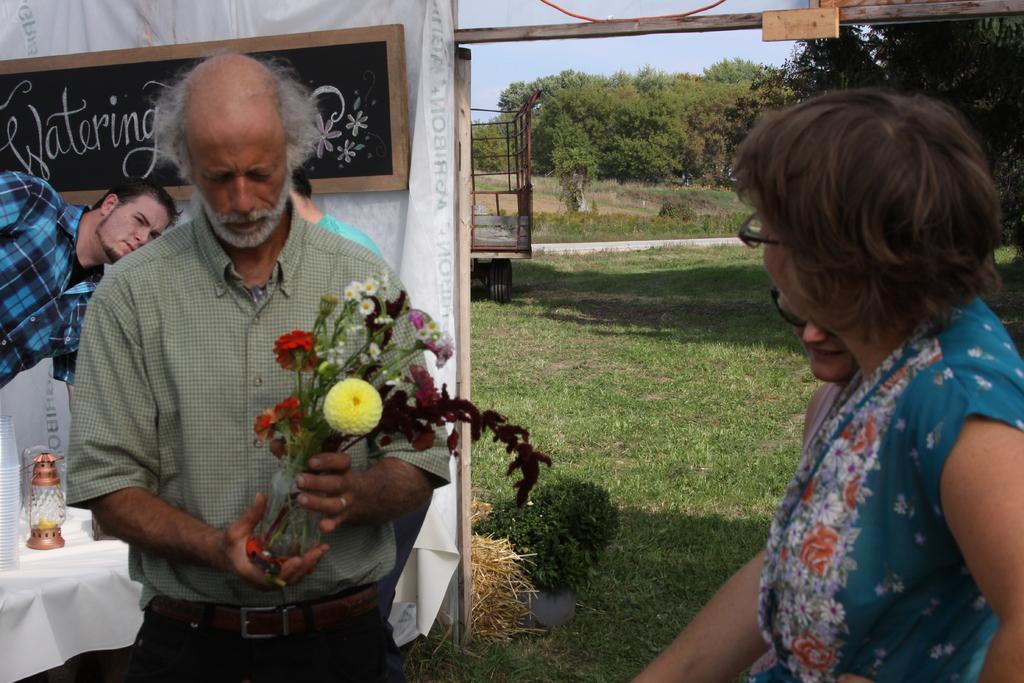Could you give a brief overview of what you see in this image? This image is taken outdoors. At the bottom of the image there is a ground with grass on it. On the right side of the image there are two women and there is a tree. On the left side of the image there is a stall with a board and text on it and there is a table with a table cloth and a few things on it. Three men are standing on the ground and a man is holding a flower vase in his hands. In the background there are a few trees and plants. 